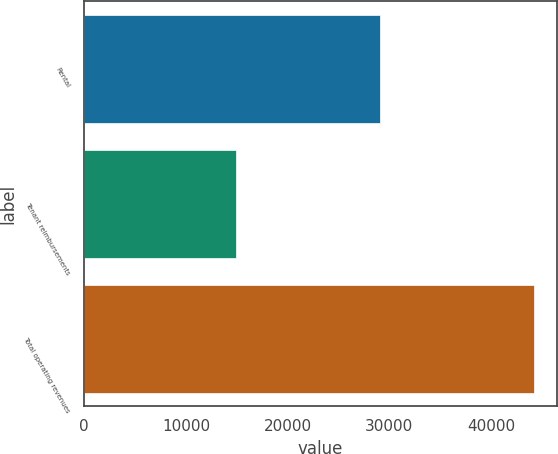Convert chart to OTSL. <chart><loc_0><loc_0><loc_500><loc_500><bar_chart><fcel>Rental<fcel>Tenant reimbursements<fcel>Total operating revenues<nl><fcel>29062<fcel>14945<fcel>44283<nl></chart> 